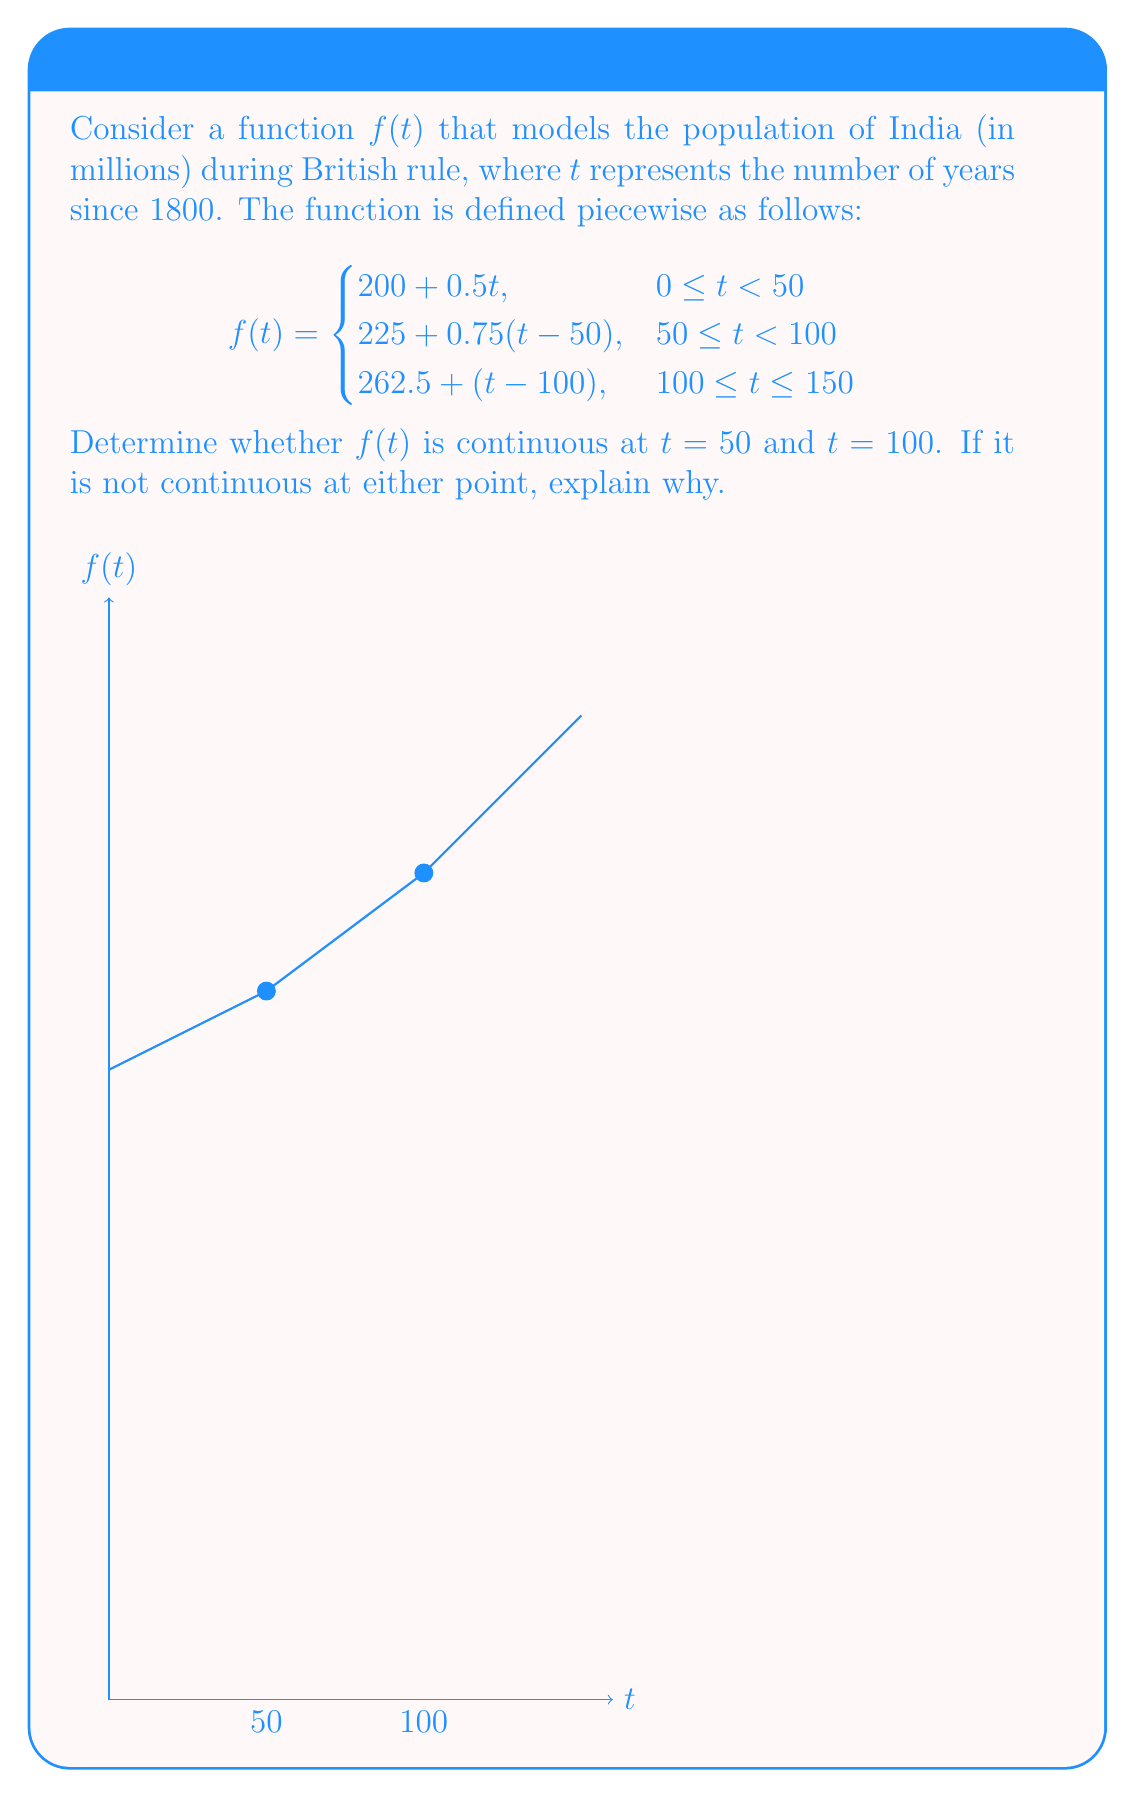Solve this math problem. To determine the continuity of $f(t)$ at $t = 50$ and $t = 100$, we need to check if the function satisfies the three conditions for continuity at these points:

1. The function is defined at the point.
2. The limit of the function exists as we approach the point from both sides.
3. The limit equals the function value at that point.

For $t = 50$:

1. $f(50)$ is defined in both pieces of the function.
2. Left-hand limit: 
   $\lim_{t \to 50^-} f(t) = \lim_{t \to 50^-} (200 + 0.5t) = 200 + 0.5(50) = 225$
   Right-hand limit:
   $\lim_{t \to 50^+} f(t) = \lim_{t \to 50^+} (225 + 0.75(t-50)) = 225 + 0.75(0) = 225$
3. $f(50) = 225$ (using either piece of the function)

Since all three conditions are satisfied, $f(t)$ is continuous at $t = 50$.

For $t = 100$:

1. $f(100)$ is defined in both pieces of the function.
2. Left-hand limit:
   $\lim_{t \to 100^-} f(t) = \lim_{t \to 100^-} (225 + 0.75(t-50)) = 225 + 0.75(50) = 262.5$
   Right-hand limit:
   $\lim_{t \to 100^+} f(t) = \lim_{t \to 100^+} (262.5 + (t-100)) = 262.5 + 0 = 262.5$
3. $f(100) = 262.5$ (using either piece of the function)

Since all three conditions are satisfied, $f(t)$ is continuous at $t = 100$.

Therefore, the function $f(t)$ is continuous at both $t = 50$ and $t = 100$.
Answer: $f(t)$ is continuous at both $t = 50$ and $t = 100$. 